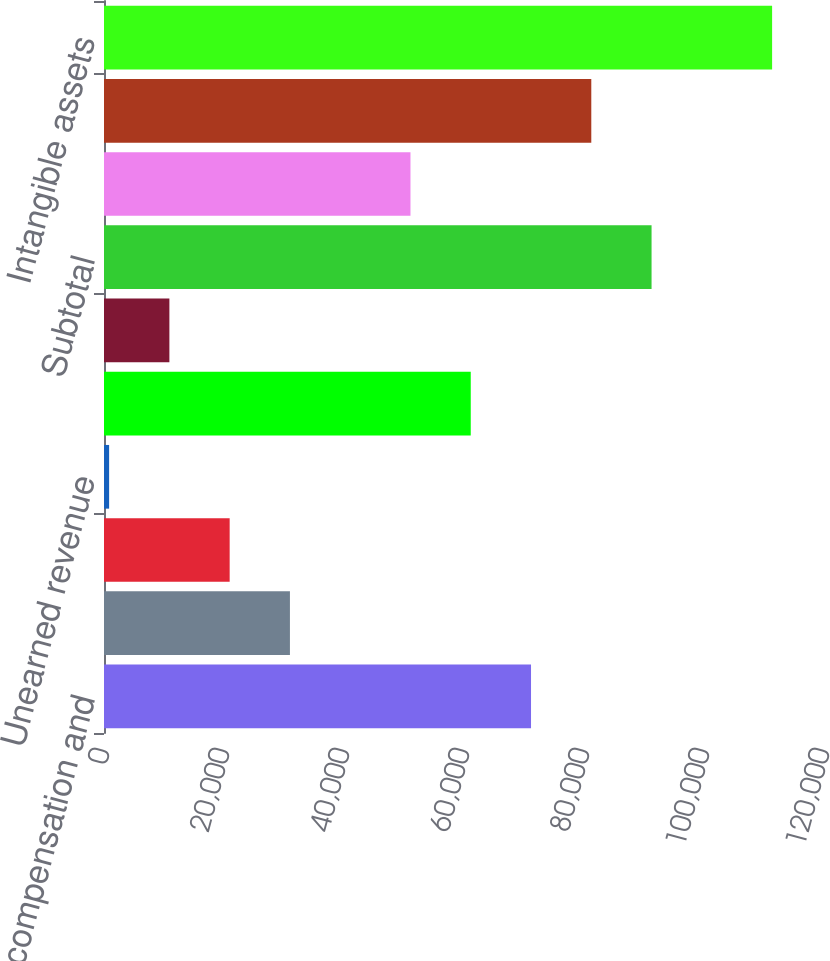Convert chart. <chart><loc_0><loc_0><loc_500><loc_500><bar_chart><fcel>Employee compensation and<fcel>Deferred rent<fcel>Pension<fcel>Unearned revenue<fcel>Loss carryforwards -<fcel>Other<fcel>Subtotal<fcel>Less valuation allowance<fcel>Total deferred tax assets<fcel>Intangible assets<nl><fcel>71170.1<fcel>30988.9<fcel>20943.6<fcel>853<fcel>61124.8<fcel>10898.3<fcel>91260.7<fcel>51079.5<fcel>81215.4<fcel>111351<nl></chart> 